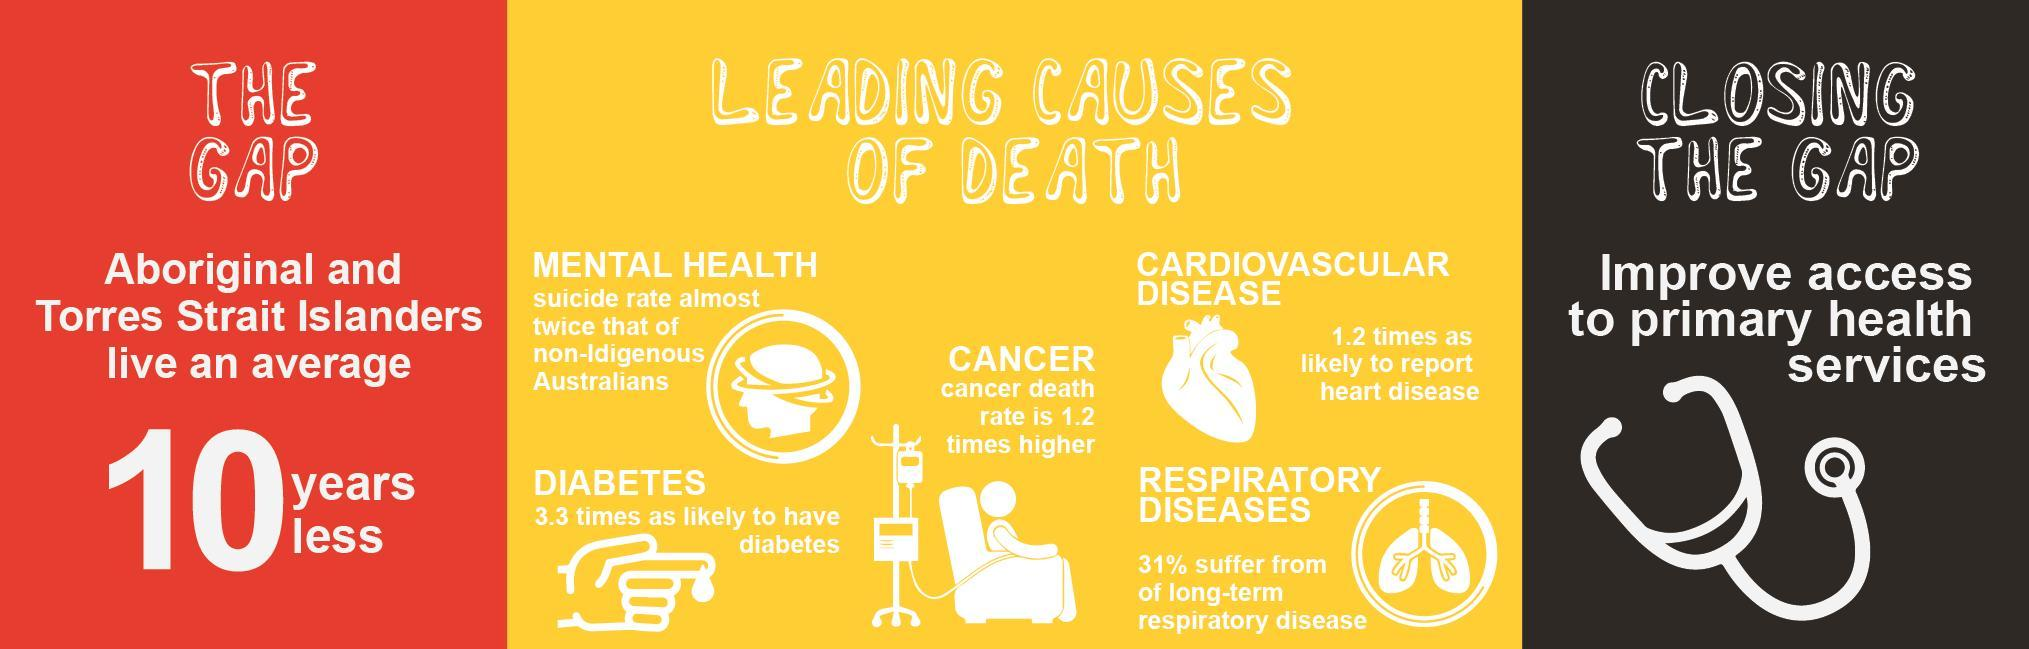How many different causes of Death are listed in the info graphic?
Answer the question with a short phrase. 5 